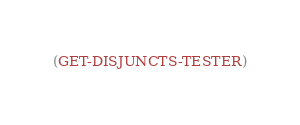<code> <loc_0><loc_0><loc_500><loc_500><_Lisp_>(GET-DISJUNCTS-TESTER)
</code> 